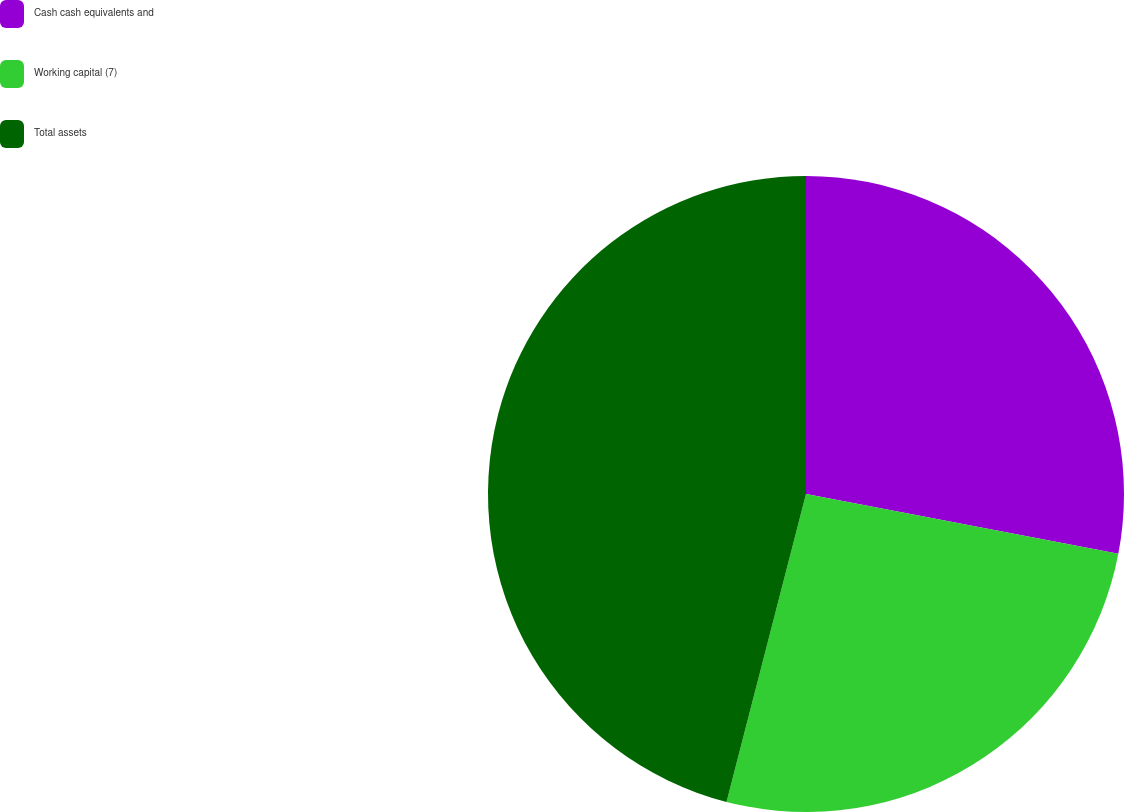Convert chart to OTSL. <chart><loc_0><loc_0><loc_500><loc_500><pie_chart><fcel>Cash cash equivalents and<fcel>Working capital (7)<fcel>Total assets<nl><fcel>28.01%<fcel>26.01%<fcel>45.98%<nl></chart> 